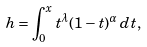Convert formula to latex. <formula><loc_0><loc_0><loc_500><loc_500>h = \int _ { 0 } ^ { x } t ^ { \lambda } ( 1 - t ) ^ { \alpha } \, d t ,</formula> 